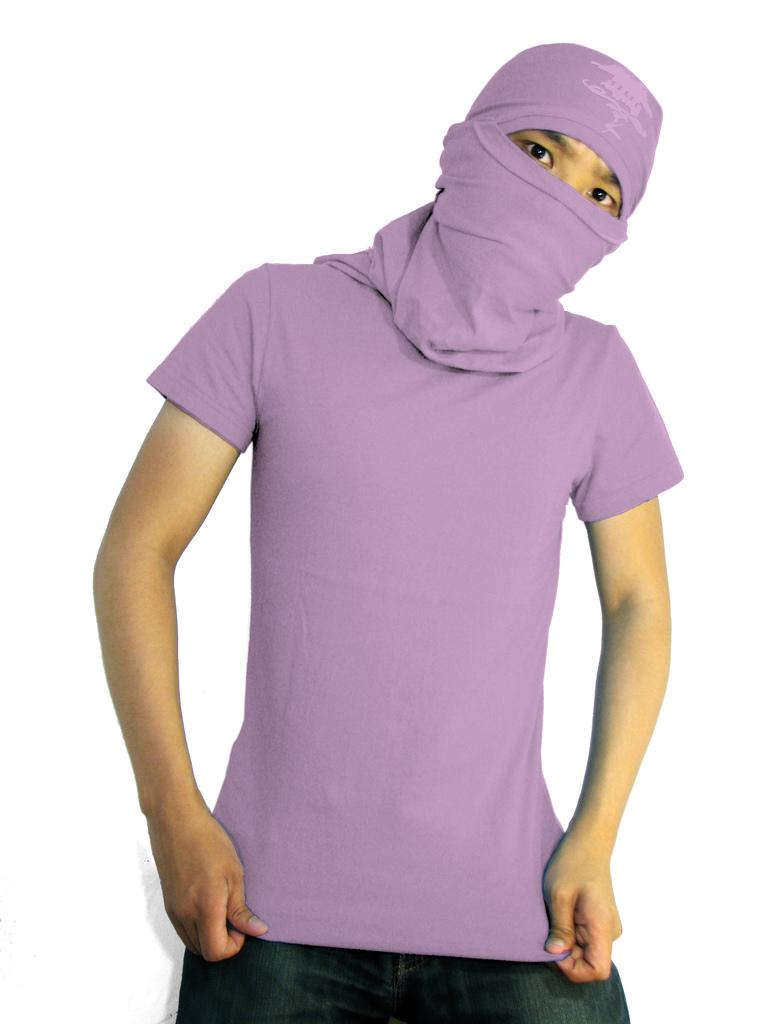Who or what is the main subject in the image? There is a person in the image. What type of clothing is the person wearing? The person is wearing a t-shirt. Is there any protective gear being worn by the person? Yes, the person is wearing a mask. What is the color of the background in the image? The background of the image is white in color. What degree is the person holding in the image? There is no degree visible in the image. Is there a lock on the person's clothing in the image? No, there is no lock present on the person's clothing in the image. 